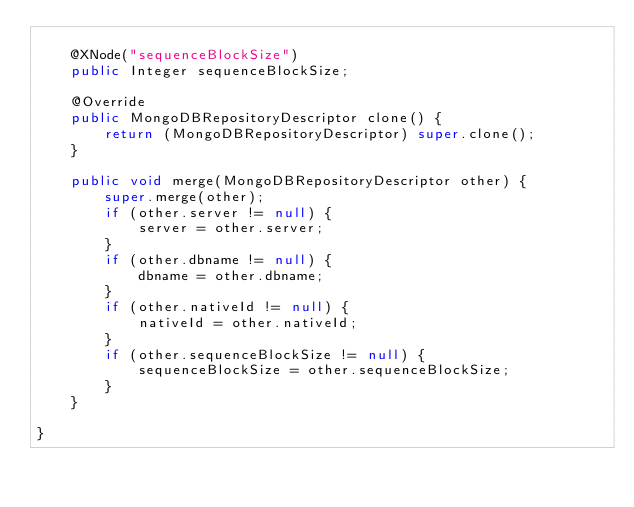Convert code to text. <code><loc_0><loc_0><loc_500><loc_500><_Java_>
    @XNode("sequenceBlockSize")
    public Integer sequenceBlockSize;

    @Override
    public MongoDBRepositoryDescriptor clone() {
        return (MongoDBRepositoryDescriptor) super.clone();
    }

    public void merge(MongoDBRepositoryDescriptor other) {
        super.merge(other);
        if (other.server != null) {
            server = other.server;
        }
        if (other.dbname != null) {
            dbname = other.dbname;
        }
        if (other.nativeId != null) {
            nativeId = other.nativeId;
        }
        if (other.sequenceBlockSize != null) {
            sequenceBlockSize = other.sequenceBlockSize;
        }
    }

}
</code> 